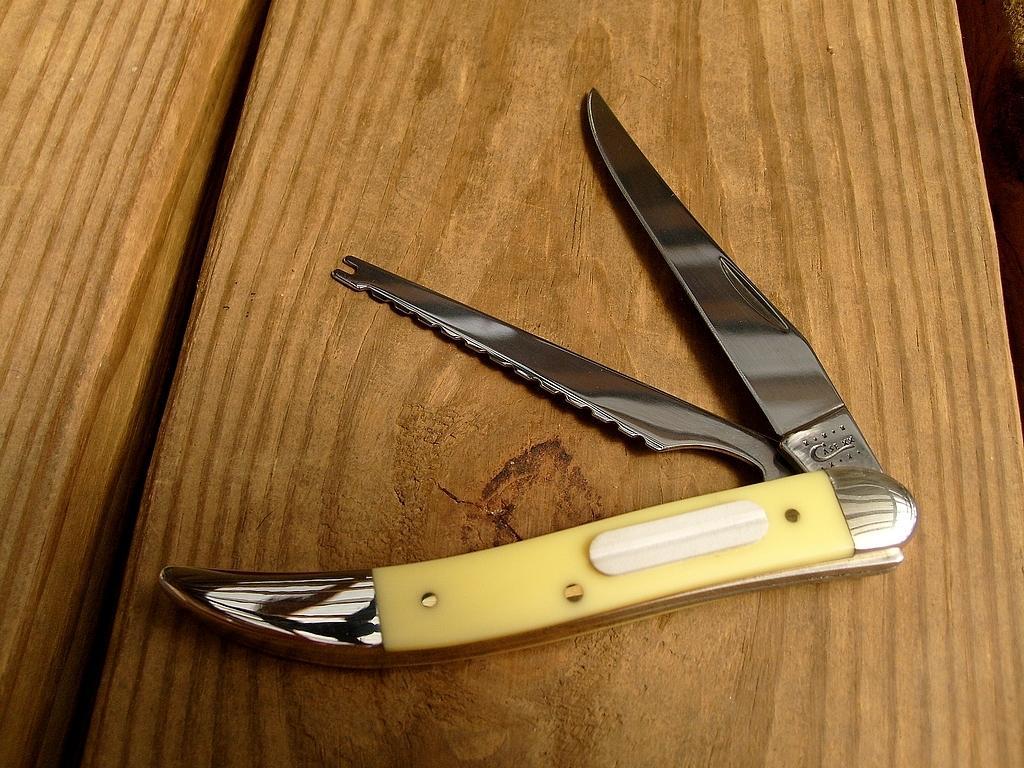Can you describe this image briefly? In the center of the image we can see knives placed on the table. 